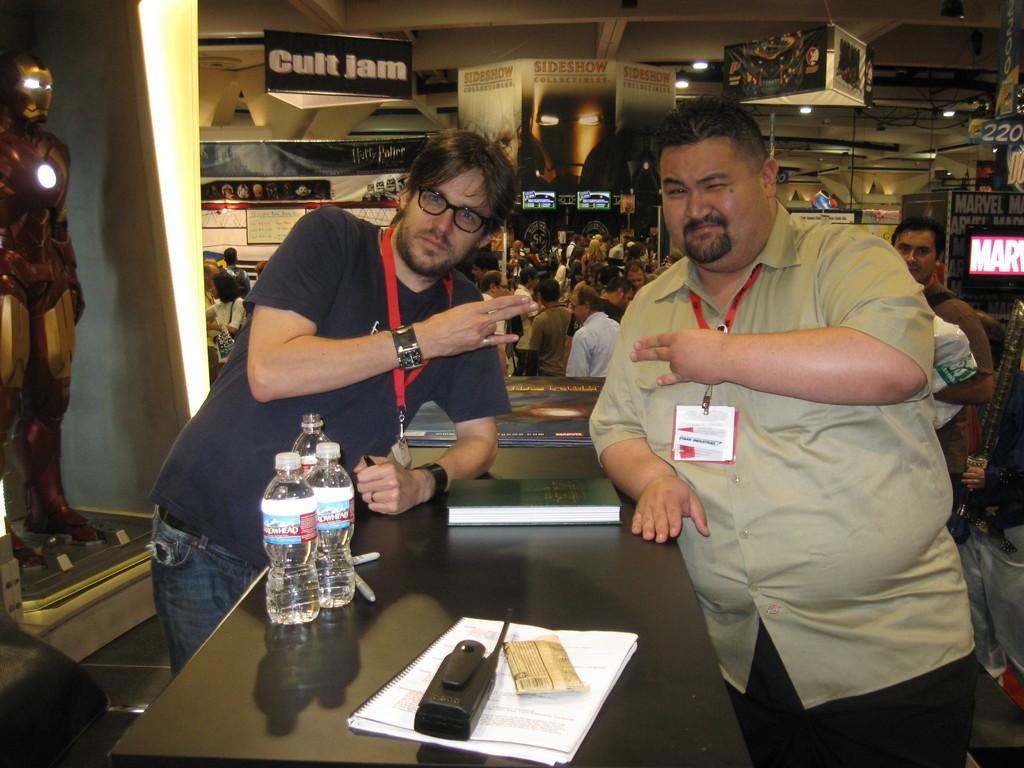Please provide a concise description of this image. In this image, we can see two men standing, there is a table, we can see water bottles and papers on the table. In the background, we can see some people sitting and we can see the walls and some posters. 